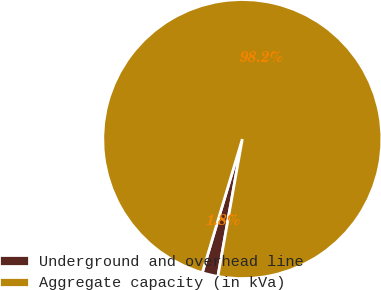<chart> <loc_0><loc_0><loc_500><loc_500><pie_chart><fcel>Underground and overhead line<fcel>Aggregate capacity (in kVa)<nl><fcel>1.83%<fcel>98.17%<nl></chart> 